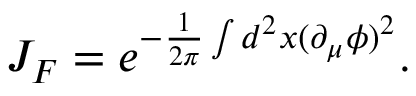Convert formula to latex. <formula><loc_0><loc_0><loc_500><loc_500>J _ { F } = e ^ { - \frac { 1 } { 2 \pi } \int d ^ { 2 } x ( \partial _ { \mu } \phi ) ^ { 2 } } .</formula> 